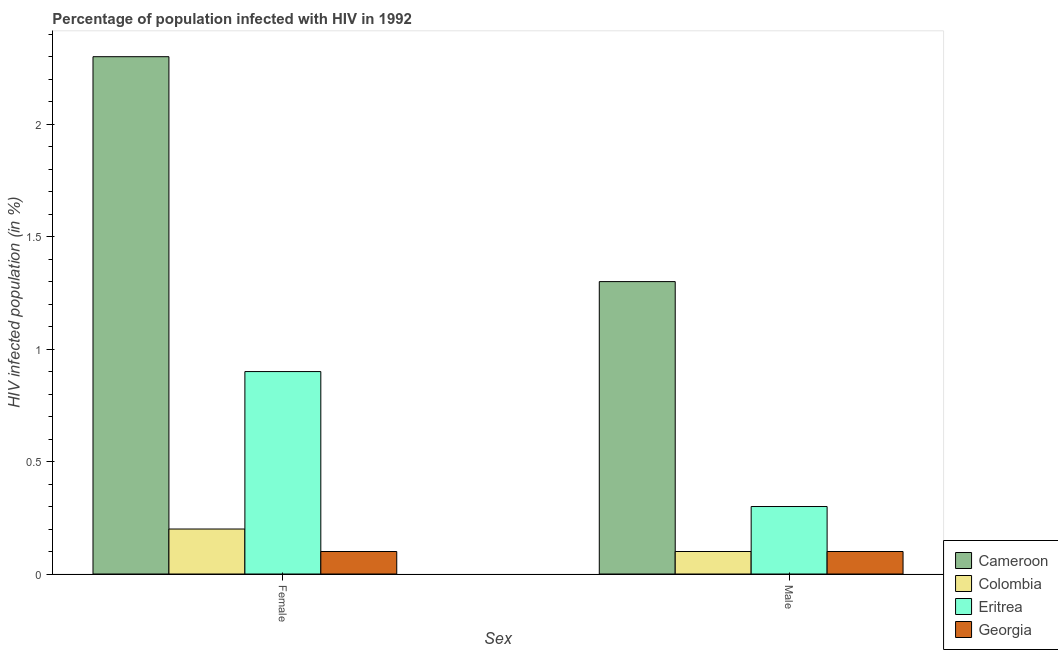How many groups of bars are there?
Your answer should be very brief. 2. Are the number of bars per tick equal to the number of legend labels?
Make the answer very short. Yes. How many bars are there on the 2nd tick from the right?
Offer a very short reply. 4. What is the percentage of males who are infected with hiv in Cameroon?
Make the answer very short. 1.3. In which country was the percentage of males who are infected with hiv maximum?
Your response must be concise. Cameroon. In which country was the percentage of females who are infected with hiv minimum?
Offer a terse response. Georgia. What is the total percentage of males who are infected with hiv in the graph?
Offer a very short reply. 1.8. What is the difference between the percentage of males who are infected with hiv in Cameroon and that in Eritrea?
Make the answer very short. 1. What is the difference between the percentage of females who are infected with hiv in Colombia and the percentage of males who are infected with hiv in Eritrea?
Give a very brief answer. -0.1. What is the difference between the percentage of females who are infected with hiv and percentage of males who are infected with hiv in Cameroon?
Your answer should be compact. 1. What is the ratio of the percentage of males who are infected with hiv in Eritrea to that in Colombia?
Provide a succinct answer. 3. Is the percentage of males who are infected with hiv in Eritrea less than that in Cameroon?
Your answer should be compact. Yes. What does the 1st bar from the right in Female represents?
Offer a terse response. Georgia. Are all the bars in the graph horizontal?
Make the answer very short. No. How many countries are there in the graph?
Your answer should be very brief. 4. Are the values on the major ticks of Y-axis written in scientific E-notation?
Make the answer very short. No. Does the graph contain any zero values?
Your response must be concise. No. Where does the legend appear in the graph?
Your answer should be very brief. Bottom right. How are the legend labels stacked?
Make the answer very short. Vertical. What is the title of the graph?
Your response must be concise. Percentage of population infected with HIV in 1992. Does "Macedonia" appear as one of the legend labels in the graph?
Make the answer very short. No. What is the label or title of the X-axis?
Provide a succinct answer. Sex. What is the label or title of the Y-axis?
Give a very brief answer. HIV infected population (in %). What is the HIV infected population (in %) of Eritrea in Female?
Your answer should be compact. 0.9. What is the HIV infected population (in %) in Colombia in Male?
Offer a very short reply. 0.1. What is the HIV infected population (in %) of Georgia in Male?
Your answer should be compact. 0.1. Across all Sex, what is the maximum HIV infected population (in %) in Cameroon?
Your answer should be compact. 2.3. Across all Sex, what is the maximum HIV infected population (in %) of Colombia?
Provide a short and direct response. 0.2. Across all Sex, what is the maximum HIV infected population (in %) of Georgia?
Offer a very short reply. 0.1. Across all Sex, what is the minimum HIV infected population (in %) in Colombia?
Offer a terse response. 0.1. Across all Sex, what is the minimum HIV infected population (in %) in Eritrea?
Ensure brevity in your answer.  0.3. Across all Sex, what is the minimum HIV infected population (in %) of Georgia?
Offer a terse response. 0.1. What is the total HIV infected population (in %) in Georgia in the graph?
Provide a succinct answer. 0.2. What is the difference between the HIV infected population (in %) in Cameroon in Female and that in Male?
Provide a short and direct response. 1. What is the difference between the HIV infected population (in %) in Eritrea in Female and that in Male?
Your response must be concise. 0.6. What is the difference between the HIV infected population (in %) in Cameroon in Female and the HIV infected population (in %) in Colombia in Male?
Your answer should be compact. 2.2. What is the difference between the HIV infected population (in %) of Cameroon in Female and the HIV infected population (in %) of Georgia in Male?
Provide a short and direct response. 2.2. What is the difference between the HIV infected population (in %) in Colombia in Female and the HIV infected population (in %) in Eritrea in Male?
Offer a very short reply. -0.1. What is the difference between the HIV infected population (in %) in Colombia in Female and the HIV infected population (in %) in Georgia in Male?
Your answer should be compact. 0.1. What is the difference between the HIV infected population (in %) of Cameroon and HIV infected population (in %) of Colombia in Female?
Provide a short and direct response. 2.1. What is the difference between the HIV infected population (in %) in Cameroon and HIV infected population (in %) in Eritrea in Female?
Offer a very short reply. 1.4. What is the difference between the HIV infected population (in %) in Colombia and HIV infected population (in %) in Georgia in Female?
Give a very brief answer. 0.1. What is the difference between the HIV infected population (in %) in Eritrea and HIV infected population (in %) in Georgia in Female?
Offer a very short reply. 0.8. What is the difference between the HIV infected population (in %) of Cameroon and HIV infected population (in %) of Colombia in Male?
Your answer should be very brief. 1.2. What is the difference between the HIV infected population (in %) of Cameroon and HIV infected population (in %) of Eritrea in Male?
Your answer should be compact. 1. What is the difference between the HIV infected population (in %) of Cameroon and HIV infected population (in %) of Georgia in Male?
Give a very brief answer. 1.2. What is the difference between the HIV infected population (in %) in Colombia and HIV infected population (in %) in Georgia in Male?
Ensure brevity in your answer.  0. What is the ratio of the HIV infected population (in %) in Cameroon in Female to that in Male?
Make the answer very short. 1.77. What is the ratio of the HIV infected population (in %) in Colombia in Female to that in Male?
Keep it short and to the point. 2. What is the ratio of the HIV infected population (in %) in Eritrea in Female to that in Male?
Provide a short and direct response. 3. What is the difference between the highest and the second highest HIV infected population (in %) in Georgia?
Ensure brevity in your answer.  0. What is the difference between the highest and the lowest HIV infected population (in %) in Cameroon?
Ensure brevity in your answer.  1. What is the difference between the highest and the lowest HIV infected population (in %) in Colombia?
Your answer should be very brief. 0.1. 